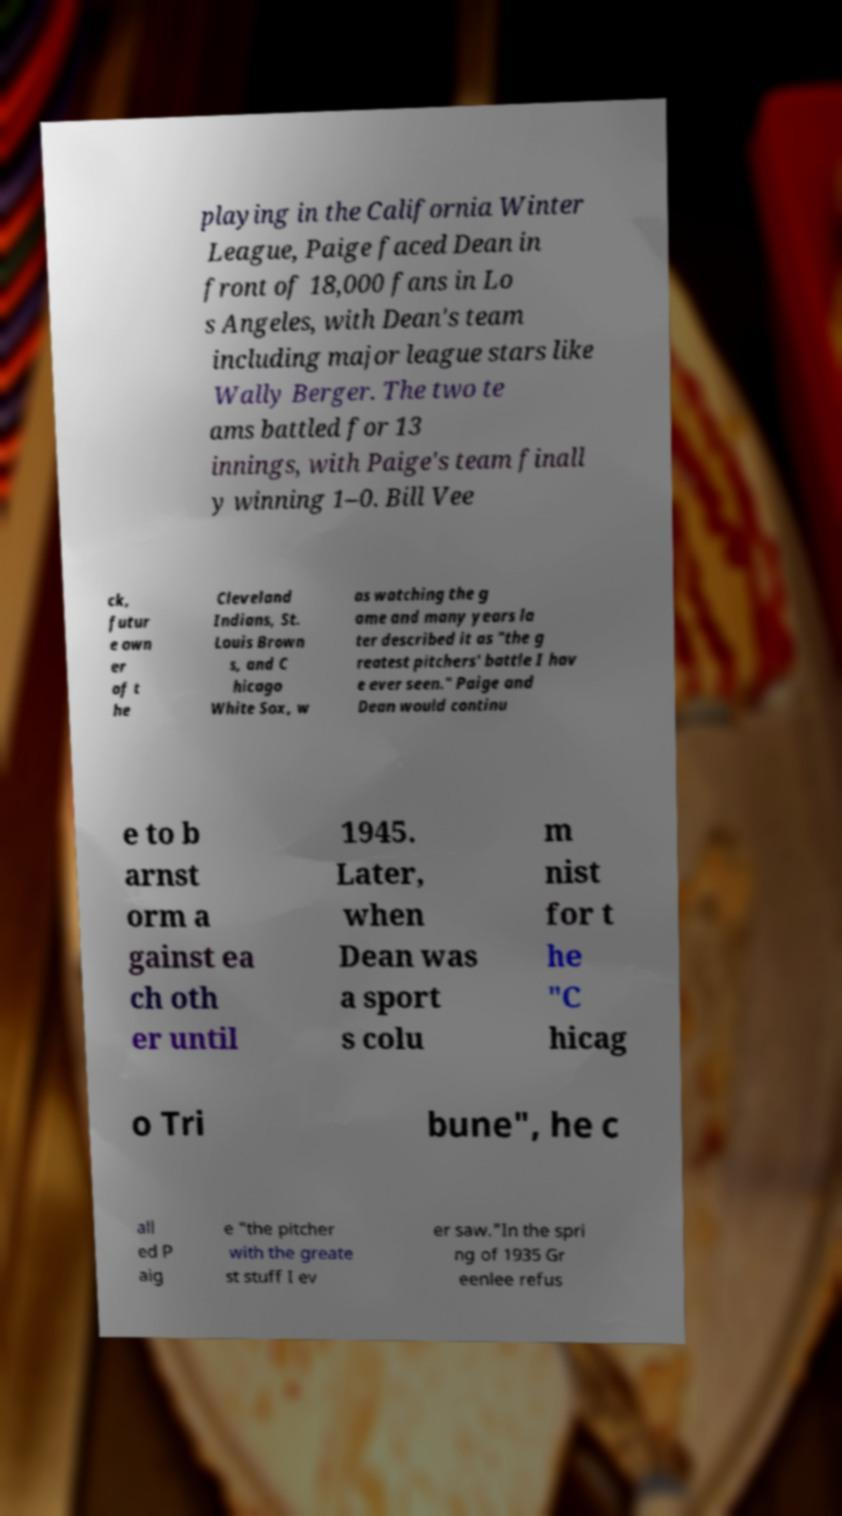Can you accurately transcribe the text from the provided image for me? playing in the California Winter League, Paige faced Dean in front of 18,000 fans in Lo s Angeles, with Dean's team including major league stars like Wally Berger. The two te ams battled for 13 innings, with Paige's team finall y winning 1–0. Bill Vee ck, futur e own er of t he Cleveland Indians, St. Louis Brown s, and C hicago White Sox, w as watching the g ame and many years la ter described it as "the g reatest pitchers' battle I hav e ever seen." Paige and Dean would continu e to b arnst orm a gainst ea ch oth er until 1945. Later, when Dean was a sport s colu m nist for t he "C hicag o Tri bune", he c all ed P aig e "the pitcher with the greate st stuff I ev er saw."In the spri ng of 1935 Gr eenlee refus 